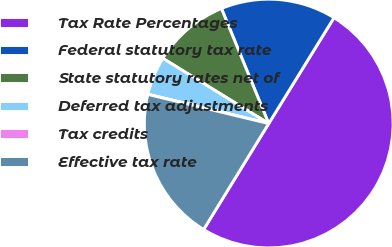Convert chart to OTSL. <chart><loc_0><loc_0><loc_500><loc_500><pie_chart><fcel>Tax Rate Percentages<fcel>Federal statutory tax rate<fcel>State statutory rates net of<fcel>Deferred tax adjustments<fcel>Tax credits<fcel>Effective tax rate<nl><fcel>49.97%<fcel>15.0%<fcel>10.01%<fcel>5.01%<fcel>0.01%<fcel>20.0%<nl></chart> 